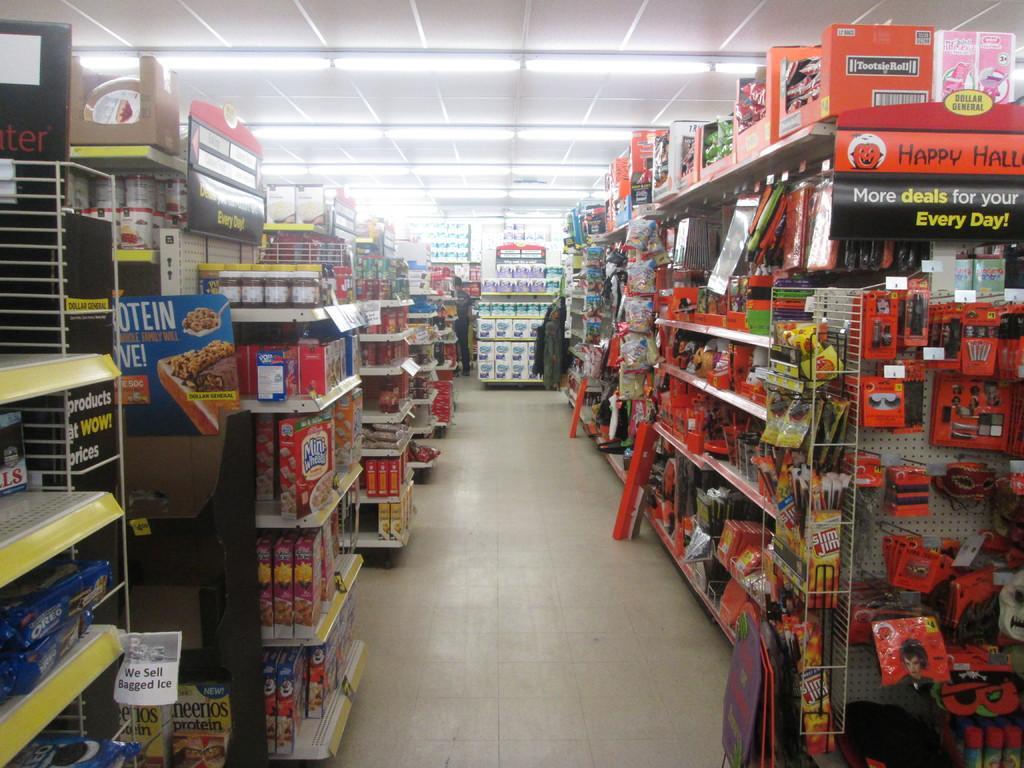Describe this image in one or two sentences. In this picture there is a grocery store in the image and there are cracks on the right and left side of the image, there are lights at the top side of the image. 